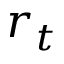<formula> <loc_0><loc_0><loc_500><loc_500>r _ { t }</formula> 